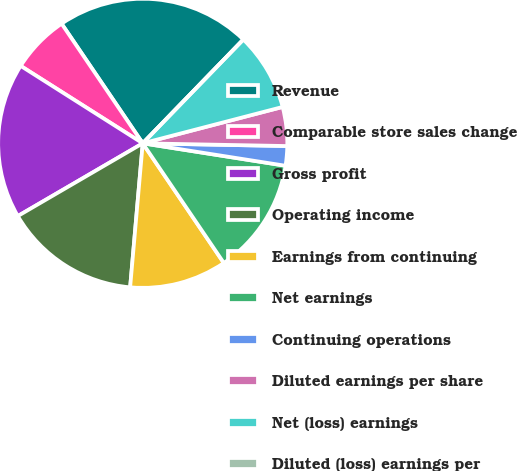<chart> <loc_0><loc_0><loc_500><loc_500><pie_chart><fcel>Revenue<fcel>Comparable store sales change<fcel>Gross profit<fcel>Operating income<fcel>Earnings from continuing<fcel>Net earnings<fcel>Continuing operations<fcel>Diluted earnings per share<fcel>Net (loss) earnings<fcel>Diluted (loss) earnings per<nl><fcel>21.74%<fcel>6.52%<fcel>17.39%<fcel>15.22%<fcel>10.87%<fcel>13.04%<fcel>2.18%<fcel>4.35%<fcel>8.7%<fcel>0.0%<nl></chart> 